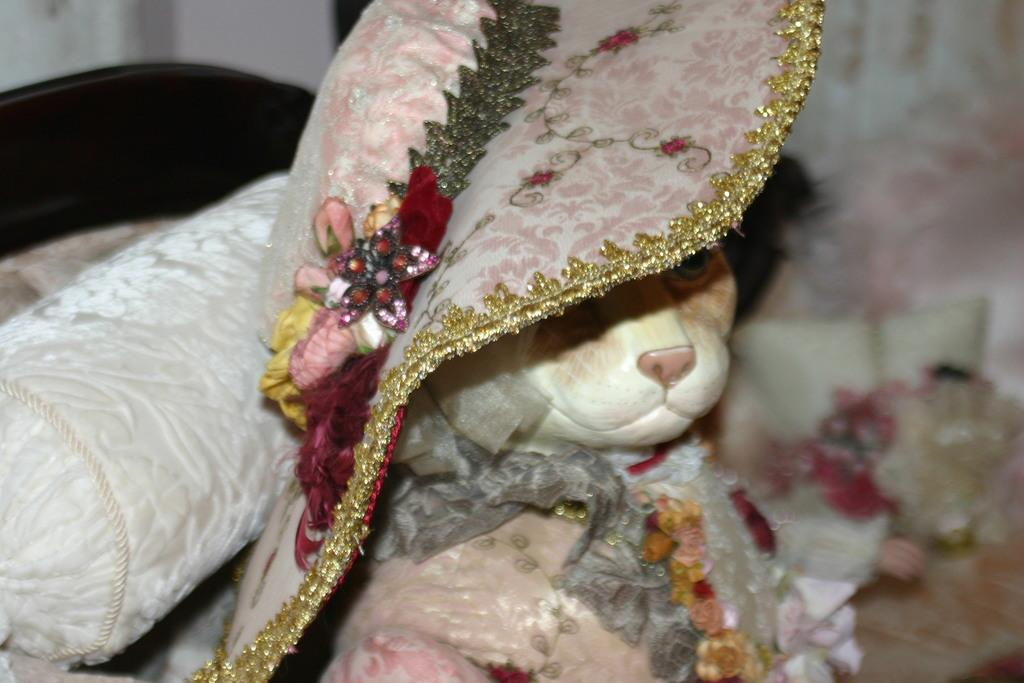What is the main subject in the center of the image? There is a cat in the center of the image. What is the cat wearing? The cat is wearing a hat. What can be seen on the left side of the image? There is a pillow on the left side of the image. What is visible in the background of the image? There are objects visible in the background of the image. What type of wound can be seen on the cat's paw in the image? There is no wound visible on the cat's paw in the image. What advice is the cat giving to the viewer in the image? The image does not depict the cat giving any advice to the viewer. 